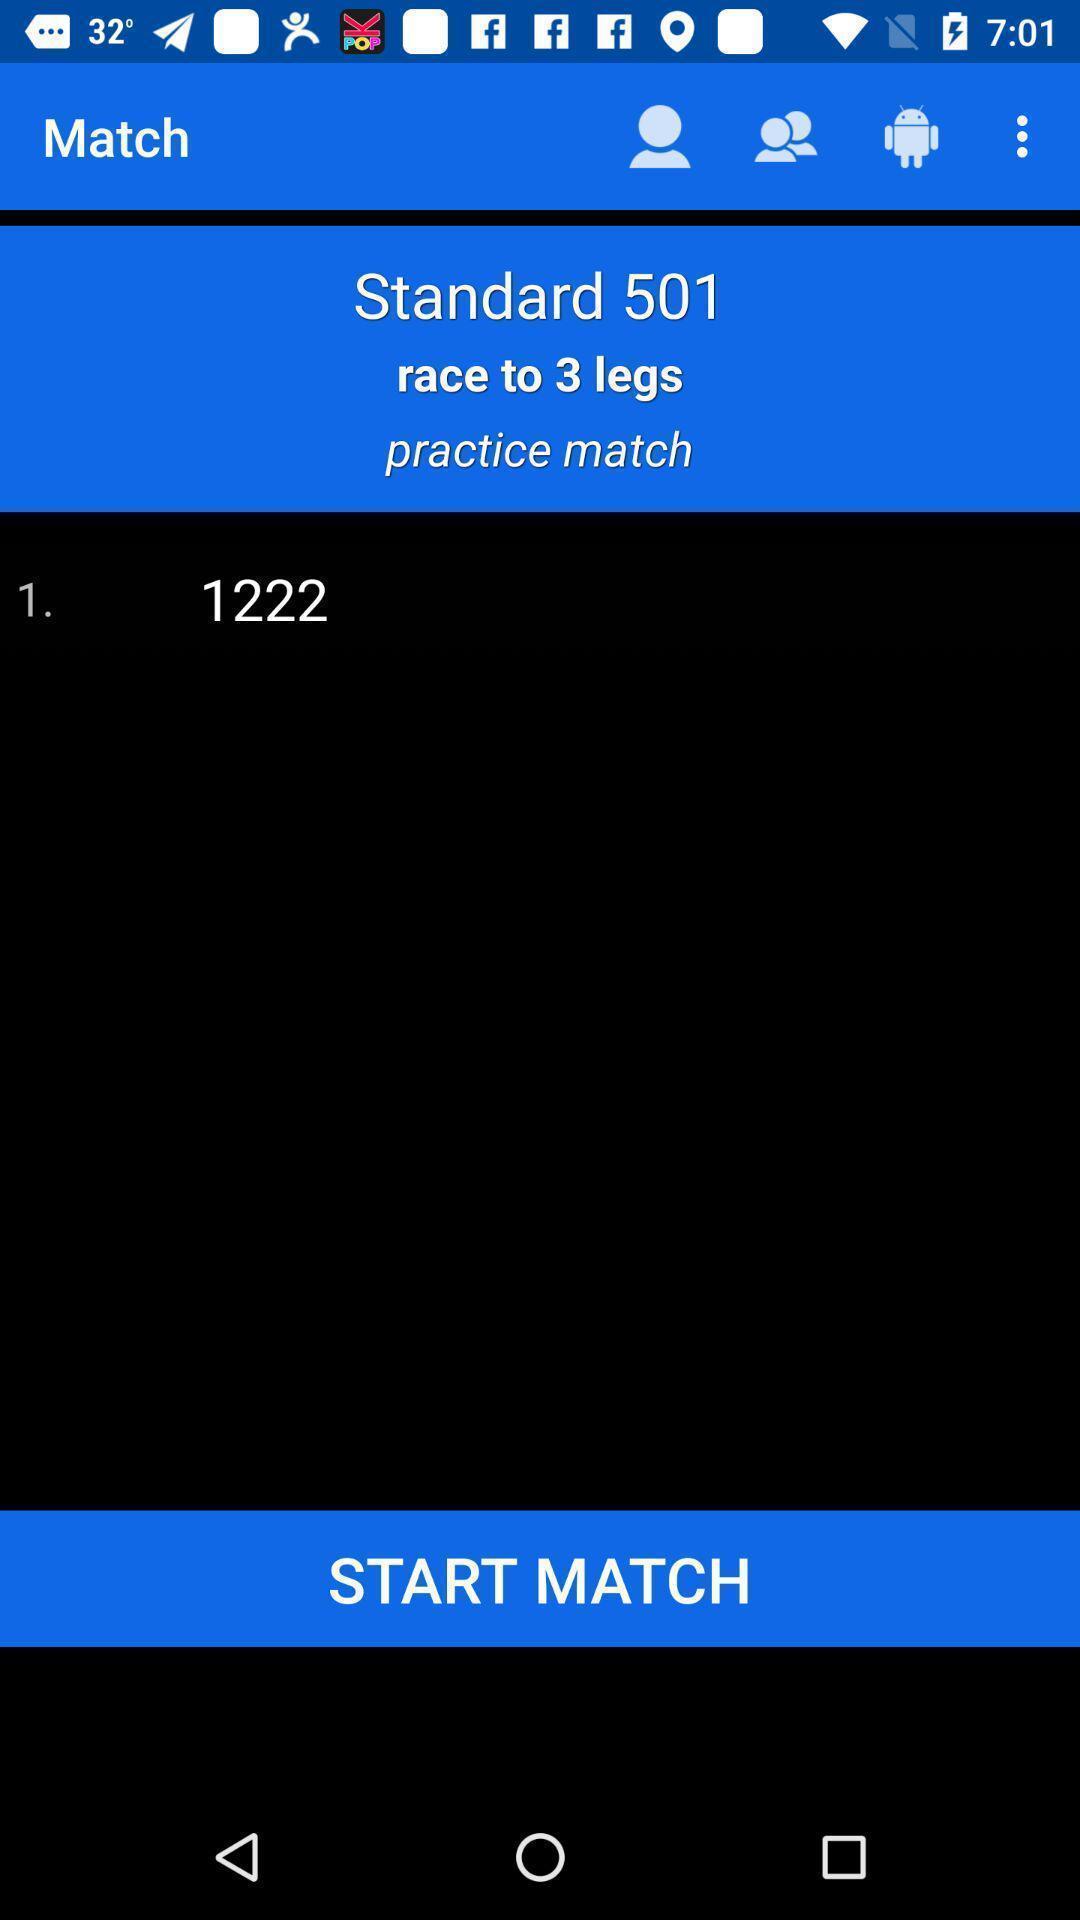Please provide a description for this image. Screen shows start match option in a sports app. 